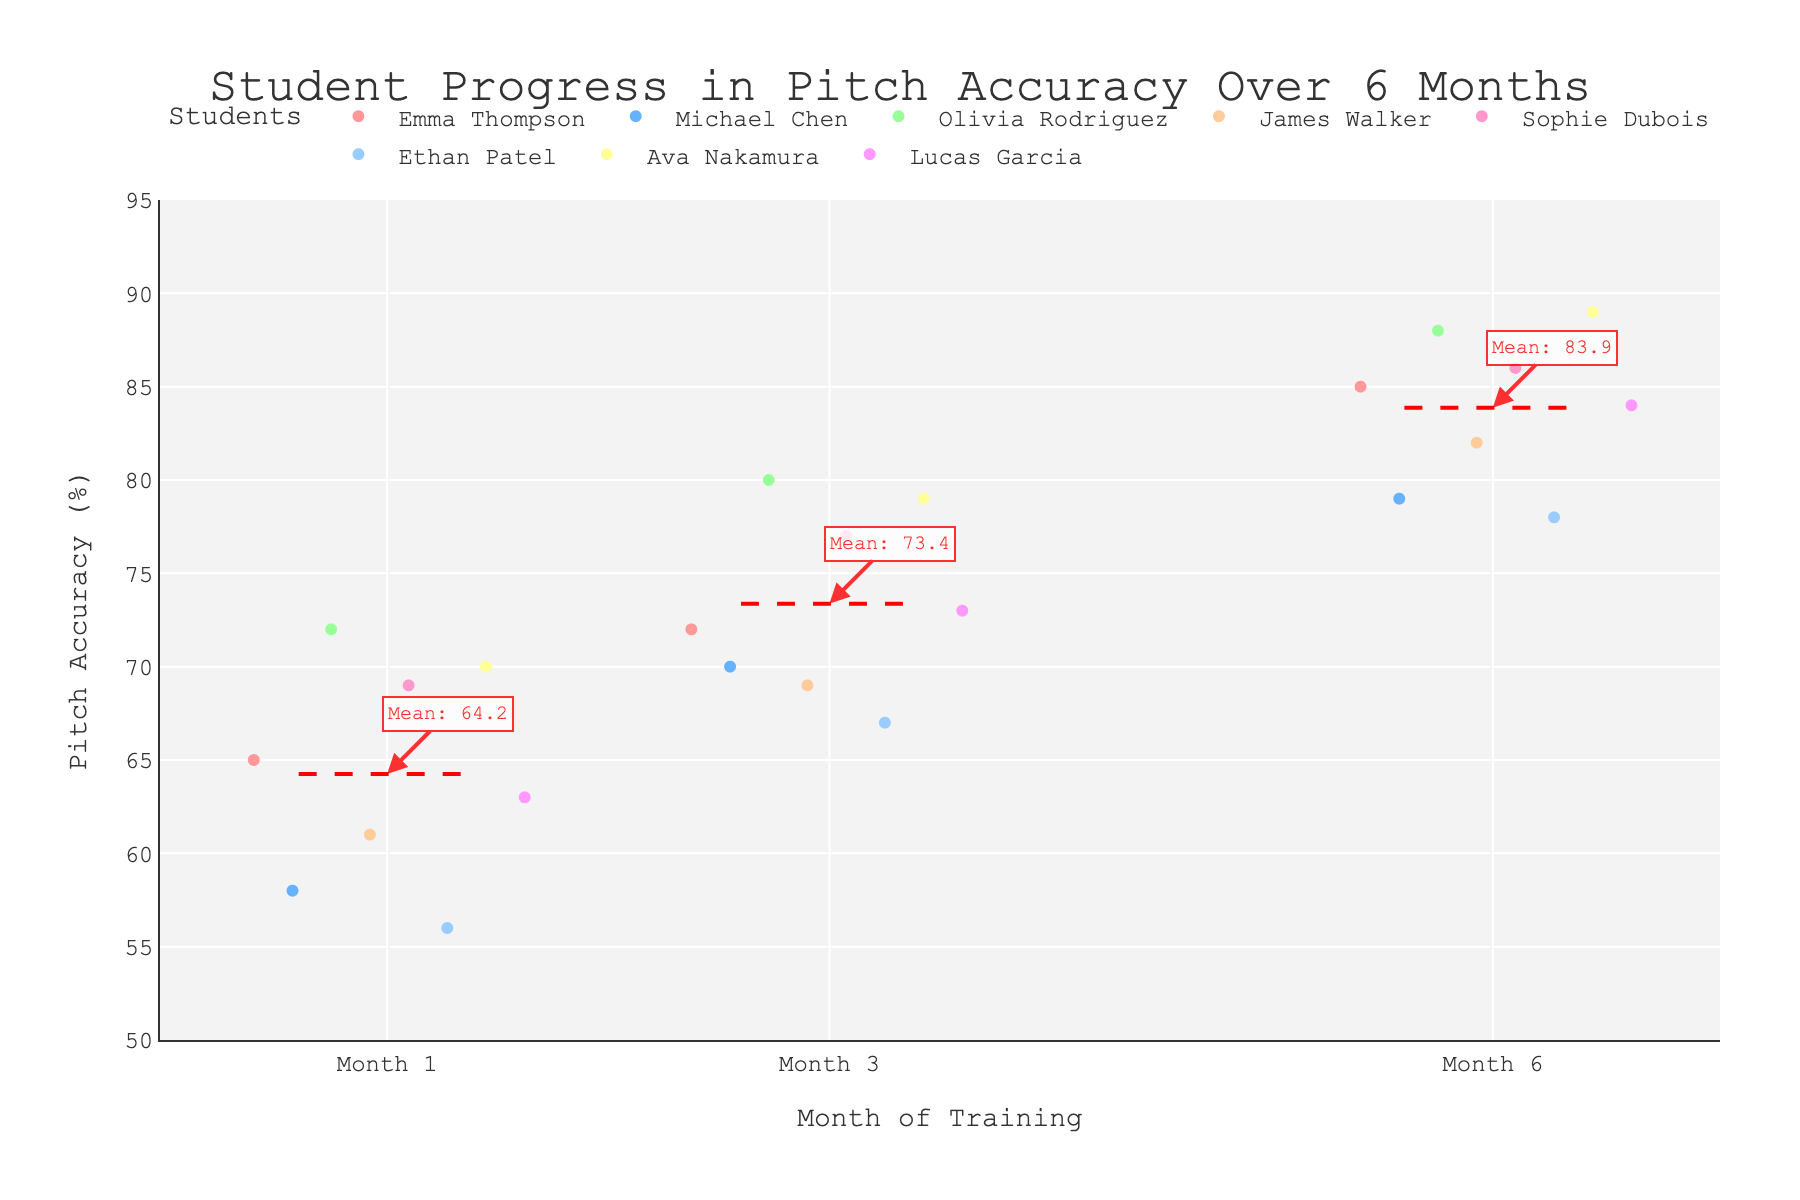What's the title of the figure? The title is usually at the top of the figure and summarizes what the plot is about. Looking at the image, the title reads "Student Progress in Pitch Accuracy Over 6 Months".
Answer: Student Progress in Pitch Accuracy Over 6 Months At which month do students generally have the highest pitch accuracy? The X-axis shows the months of training, and the Y-axis shows pitch accuracy. By observing the strip plot, we see that pitch accuracy is higher at month 6 for most students.
Answer: 6 What is the mean pitch accuracy for month 3? Mean lines are added for each month, and for month 3, the annotation shows the mean value. The annotation in red next to month 3 indicates the mean pitch accuracy.
Answer: 73.5 Which student had the highest pitch accuracy at month 6? The data points for each student at month 6 on the X-axis need to be compared. The highest point is for Ava Nakamura.
Answer: Ava Nakamura How does Emma Thompson's pitch accuracy progress from month 1 to month 6? We need to trace Emma Thompson's points across the months. At month 1, her accuracy is 65, progresses to 72 in month 3, and reaches 85 by month 6.
Answer: 65 → 72 → 85 Can you identify a student with the least improvement in pitch accuracy over the 6-month period? Compare the difference between month 6 and month 1 accuracies for each student. Michael Chen's progress is 79 - 58 = 21, which is the smallest improvement.
Answer: Michael Chen What is the range of pitch accuracy at month 1? To find the range, identify the highest and lowest data points at month 1 on the strip plot. The highest is Olivia Rodriguez with 72, and the lowest is Ethan Patel with 56. The range is 72 - 56.
Answer: 16 Who has the most steady improvement in pitch accuracy over the 6 months? Steady improvement means consistent increases without any dips. Sophie Dubois has a steady improvement: 69 → 77 → 86.
Answer: Sophie Dubois Which months have a red dashed mean line that indicates the highest mean pitch accuracy? The red dashed mean lines at each month indicate the collective mean. Observing these lines, month 6 has the highest mean pitch accuracy.
Answer: 6 On which month does Lucas Garcia reach a pitch accuracy of 84%? Locate Lucas Garcia's points across the plot. His point at month 6 shows a pitch accuracy of 84.
Answer: 6 